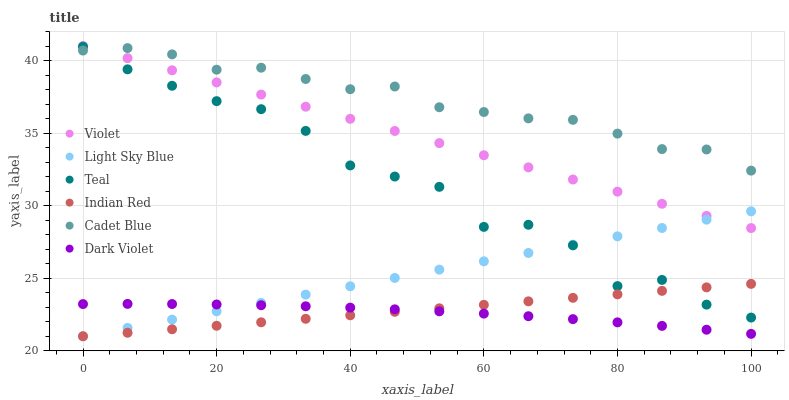Does Dark Violet have the minimum area under the curve?
Answer yes or no. Yes. Does Cadet Blue have the maximum area under the curve?
Answer yes or no. Yes. Does Teal have the minimum area under the curve?
Answer yes or no. No. Does Teal have the maximum area under the curve?
Answer yes or no. No. Is Indian Red the smoothest?
Answer yes or no. Yes. Is Teal the roughest?
Answer yes or no. Yes. Is Dark Violet the smoothest?
Answer yes or no. No. Is Dark Violet the roughest?
Answer yes or no. No. Does Light Sky Blue have the lowest value?
Answer yes or no. Yes. Does Teal have the lowest value?
Answer yes or no. No. Does Violet have the highest value?
Answer yes or no. Yes. Does Teal have the highest value?
Answer yes or no. No. Is Dark Violet less than Violet?
Answer yes or no. Yes. Is Cadet Blue greater than Light Sky Blue?
Answer yes or no. Yes. Does Light Sky Blue intersect Dark Violet?
Answer yes or no. Yes. Is Light Sky Blue less than Dark Violet?
Answer yes or no. No. Is Light Sky Blue greater than Dark Violet?
Answer yes or no. No. Does Dark Violet intersect Violet?
Answer yes or no. No. 